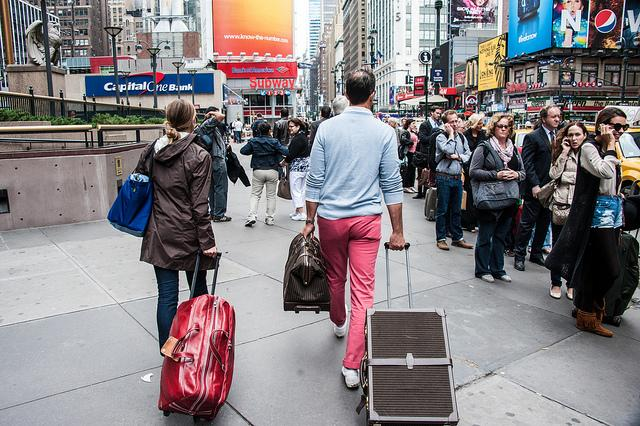The Red white and blue circular emblem on the visible billboard here advertises for what company? Please explain your reasoning. pepsi. The pepsi is the ad. 